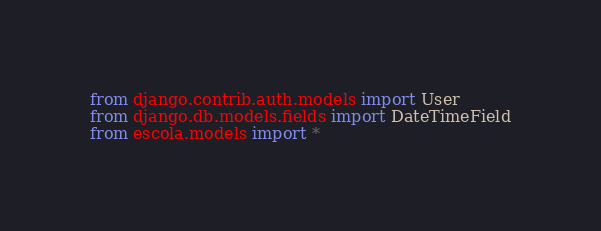<code> <loc_0><loc_0><loc_500><loc_500><_Python_>from django.contrib.auth.models import User
from django.db.models.fields import DateTimeField
from escola.models import *


</code> 